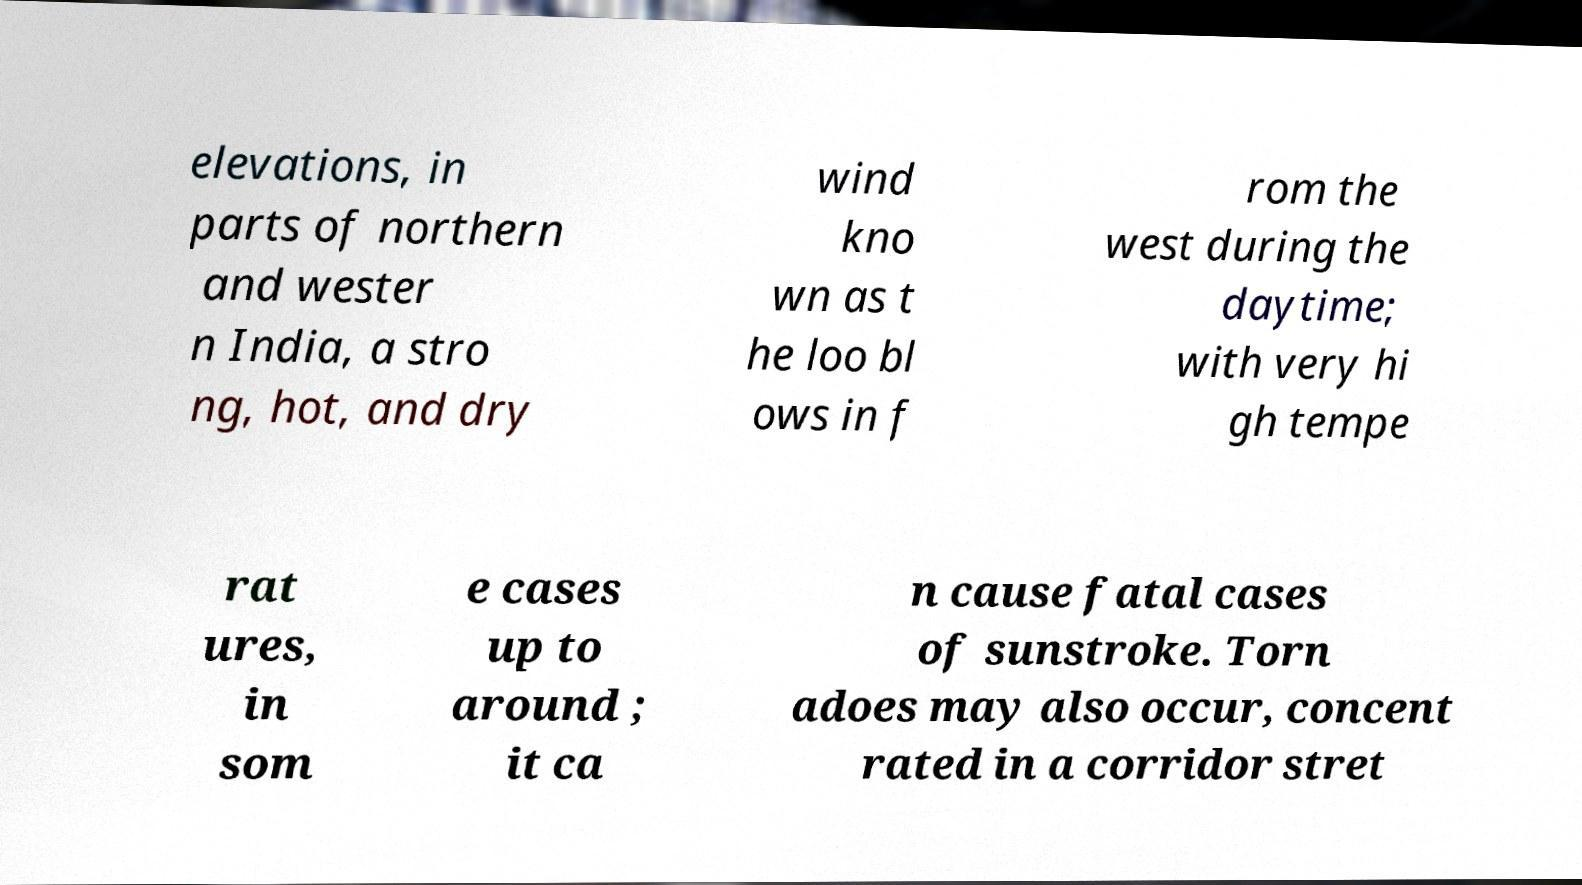Could you extract and type out the text from this image? elevations, in parts of northern and wester n India, a stro ng, hot, and dry wind kno wn as t he loo bl ows in f rom the west during the daytime; with very hi gh tempe rat ures, in som e cases up to around ; it ca n cause fatal cases of sunstroke. Torn adoes may also occur, concent rated in a corridor stret 